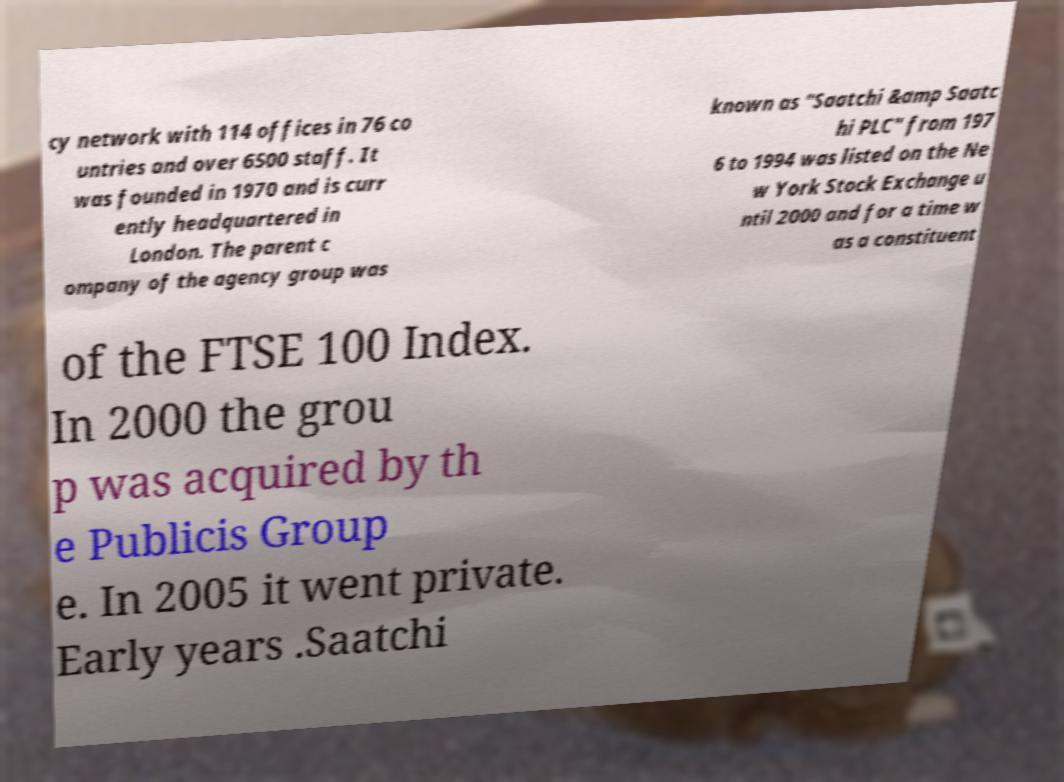For documentation purposes, I need the text within this image transcribed. Could you provide that? cy network with 114 offices in 76 co untries and over 6500 staff. It was founded in 1970 and is curr ently headquartered in London. The parent c ompany of the agency group was known as "Saatchi &amp Saatc hi PLC" from 197 6 to 1994 was listed on the Ne w York Stock Exchange u ntil 2000 and for a time w as a constituent of the FTSE 100 Index. In 2000 the grou p was acquired by th e Publicis Group e. In 2005 it went private. Early years .Saatchi 